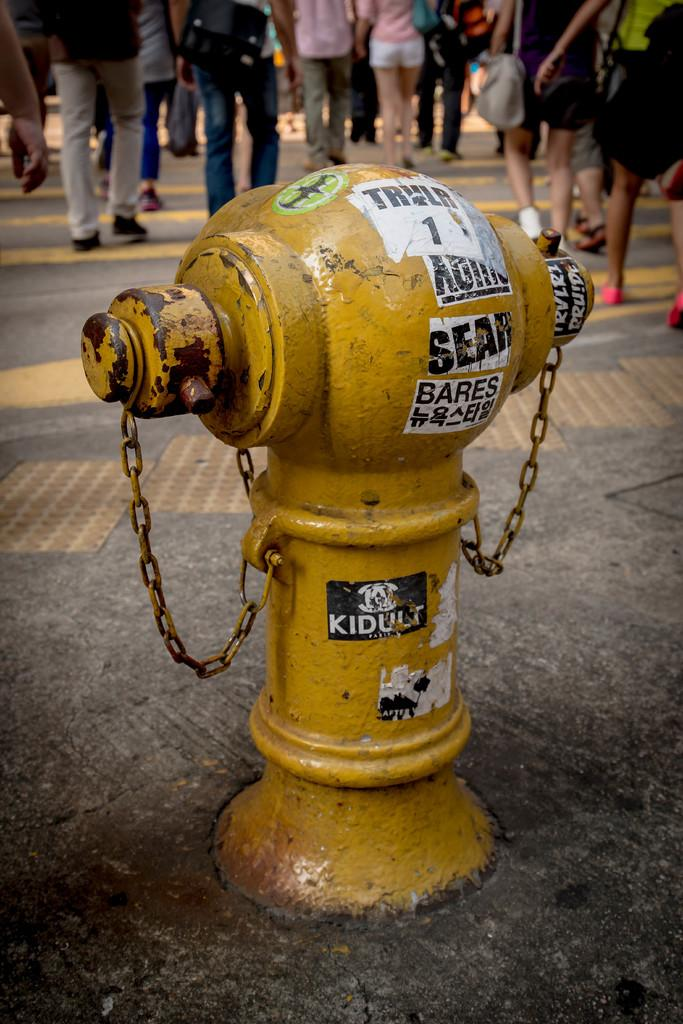What color is the fire hydrant in the image? The fire hydrant is yellow in the image. Are there any additional features on the fire hydrant? Yes, the fire hydrant has chains on it. Where is the fire hydrant located in the image? The fire hydrant is on a path in the image. What is happening behind the fire hydrant? There are people walking on the path behind the fire hydrant. What type of dress is the fire hydrant wearing in the image? Fire hydrants do not wear dresses; they are inanimate objects. 